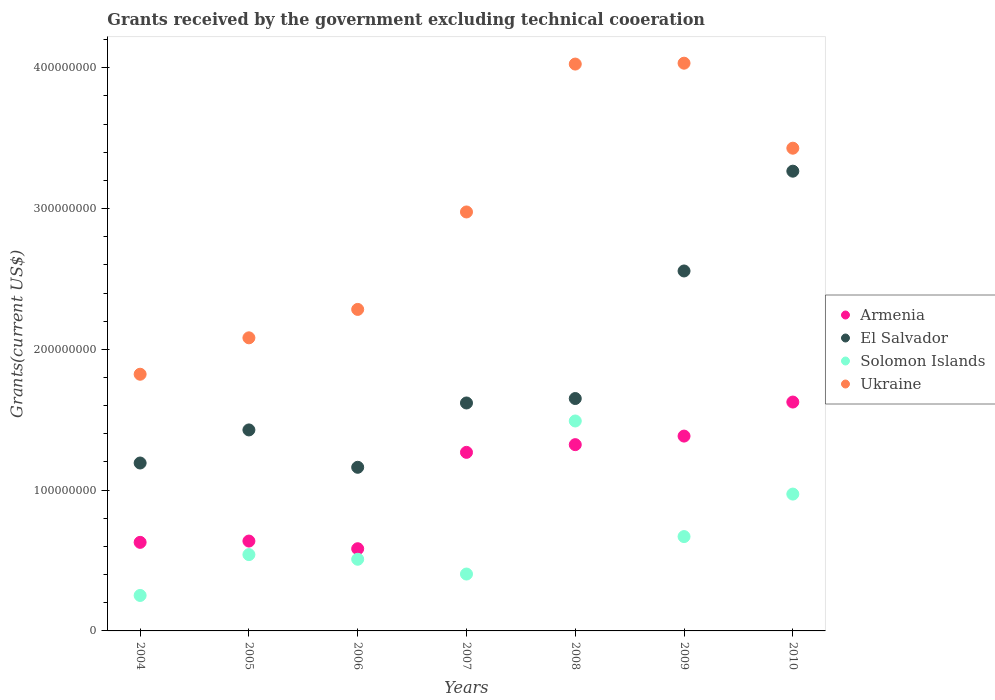How many different coloured dotlines are there?
Offer a terse response. 4. What is the total grants received by the government in Solomon Islands in 2009?
Offer a very short reply. 6.70e+07. Across all years, what is the maximum total grants received by the government in Ukraine?
Give a very brief answer. 4.03e+08. Across all years, what is the minimum total grants received by the government in Armenia?
Make the answer very short. 5.84e+07. In which year was the total grants received by the government in Armenia maximum?
Provide a short and direct response. 2010. In which year was the total grants received by the government in El Salvador minimum?
Your answer should be compact. 2006. What is the total total grants received by the government in El Salvador in the graph?
Your answer should be very brief. 1.29e+09. What is the difference between the total grants received by the government in Ukraine in 2006 and that in 2008?
Provide a short and direct response. -1.74e+08. What is the difference between the total grants received by the government in El Salvador in 2004 and the total grants received by the government in Solomon Islands in 2008?
Your answer should be very brief. -2.98e+07. What is the average total grants received by the government in El Salvador per year?
Your response must be concise. 1.84e+08. In the year 2007, what is the difference between the total grants received by the government in Ukraine and total grants received by the government in Armenia?
Ensure brevity in your answer.  1.71e+08. What is the ratio of the total grants received by the government in Armenia in 2007 to that in 2009?
Your answer should be compact. 0.92. What is the difference between the highest and the second highest total grants received by the government in Armenia?
Provide a short and direct response. 2.42e+07. What is the difference between the highest and the lowest total grants received by the government in Armenia?
Your answer should be very brief. 1.04e+08. In how many years, is the total grants received by the government in Armenia greater than the average total grants received by the government in Armenia taken over all years?
Keep it short and to the point. 4. Is the sum of the total grants received by the government in Ukraine in 2005 and 2009 greater than the maximum total grants received by the government in Armenia across all years?
Provide a short and direct response. Yes. Is the total grants received by the government in Armenia strictly greater than the total grants received by the government in Ukraine over the years?
Ensure brevity in your answer.  No. Is the total grants received by the government in Solomon Islands strictly less than the total grants received by the government in Ukraine over the years?
Offer a terse response. Yes. How many years are there in the graph?
Offer a very short reply. 7. Are the values on the major ticks of Y-axis written in scientific E-notation?
Your answer should be very brief. No. Where does the legend appear in the graph?
Give a very brief answer. Center right. How are the legend labels stacked?
Your answer should be compact. Vertical. What is the title of the graph?
Offer a terse response. Grants received by the government excluding technical cooeration. Does "Fragile and conflict affected situations" appear as one of the legend labels in the graph?
Keep it short and to the point. No. What is the label or title of the X-axis?
Your answer should be compact. Years. What is the label or title of the Y-axis?
Keep it short and to the point. Grants(current US$). What is the Grants(current US$) in Armenia in 2004?
Provide a short and direct response. 6.29e+07. What is the Grants(current US$) of El Salvador in 2004?
Your answer should be very brief. 1.19e+08. What is the Grants(current US$) in Solomon Islands in 2004?
Your answer should be very brief. 2.52e+07. What is the Grants(current US$) in Ukraine in 2004?
Your response must be concise. 1.82e+08. What is the Grants(current US$) in Armenia in 2005?
Provide a succinct answer. 6.38e+07. What is the Grants(current US$) in El Salvador in 2005?
Keep it short and to the point. 1.43e+08. What is the Grants(current US$) in Solomon Islands in 2005?
Your answer should be very brief. 5.42e+07. What is the Grants(current US$) of Ukraine in 2005?
Keep it short and to the point. 2.08e+08. What is the Grants(current US$) in Armenia in 2006?
Give a very brief answer. 5.84e+07. What is the Grants(current US$) of El Salvador in 2006?
Offer a terse response. 1.16e+08. What is the Grants(current US$) in Solomon Islands in 2006?
Your response must be concise. 5.09e+07. What is the Grants(current US$) of Ukraine in 2006?
Ensure brevity in your answer.  2.28e+08. What is the Grants(current US$) of Armenia in 2007?
Offer a very short reply. 1.27e+08. What is the Grants(current US$) of El Salvador in 2007?
Provide a succinct answer. 1.62e+08. What is the Grants(current US$) of Solomon Islands in 2007?
Provide a short and direct response. 4.04e+07. What is the Grants(current US$) of Ukraine in 2007?
Your response must be concise. 2.98e+08. What is the Grants(current US$) in Armenia in 2008?
Give a very brief answer. 1.32e+08. What is the Grants(current US$) of El Salvador in 2008?
Your response must be concise. 1.65e+08. What is the Grants(current US$) of Solomon Islands in 2008?
Give a very brief answer. 1.49e+08. What is the Grants(current US$) of Ukraine in 2008?
Keep it short and to the point. 4.03e+08. What is the Grants(current US$) of Armenia in 2009?
Provide a succinct answer. 1.38e+08. What is the Grants(current US$) in El Salvador in 2009?
Make the answer very short. 2.56e+08. What is the Grants(current US$) of Solomon Islands in 2009?
Ensure brevity in your answer.  6.70e+07. What is the Grants(current US$) of Ukraine in 2009?
Ensure brevity in your answer.  4.03e+08. What is the Grants(current US$) in Armenia in 2010?
Ensure brevity in your answer.  1.63e+08. What is the Grants(current US$) of El Salvador in 2010?
Offer a terse response. 3.27e+08. What is the Grants(current US$) in Solomon Islands in 2010?
Provide a succinct answer. 9.72e+07. What is the Grants(current US$) in Ukraine in 2010?
Keep it short and to the point. 3.43e+08. Across all years, what is the maximum Grants(current US$) in Armenia?
Provide a succinct answer. 1.63e+08. Across all years, what is the maximum Grants(current US$) of El Salvador?
Your answer should be compact. 3.27e+08. Across all years, what is the maximum Grants(current US$) in Solomon Islands?
Ensure brevity in your answer.  1.49e+08. Across all years, what is the maximum Grants(current US$) of Ukraine?
Give a very brief answer. 4.03e+08. Across all years, what is the minimum Grants(current US$) of Armenia?
Keep it short and to the point. 5.84e+07. Across all years, what is the minimum Grants(current US$) of El Salvador?
Your answer should be very brief. 1.16e+08. Across all years, what is the minimum Grants(current US$) of Solomon Islands?
Provide a short and direct response. 2.52e+07. Across all years, what is the minimum Grants(current US$) of Ukraine?
Your answer should be compact. 1.82e+08. What is the total Grants(current US$) in Armenia in the graph?
Make the answer very short. 7.45e+08. What is the total Grants(current US$) in El Salvador in the graph?
Keep it short and to the point. 1.29e+09. What is the total Grants(current US$) in Solomon Islands in the graph?
Make the answer very short. 4.84e+08. What is the total Grants(current US$) in Ukraine in the graph?
Your answer should be very brief. 2.07e+09. What is the difference between the Grants(current US$) of Armenia in 2004 and that in 2005?
Give a very brief answer. -9.10e+05. What is the difference between the Grants(current US$) in El Salvador in 2004 and that in 2005?
Keep it short and to the point. -2.35e+07. What is the difference between the Grants(current US$) of Solomon Islands in 2004 and that in 2005?
Offer a terse response. -2.90e+07. What is the difference between the Grants(current US$) of Ukraine in 2004 and that in 2005?
Keep it short and to the point. -2.59e+07. What is the difference between the Grants(current US$) in Armenia in 2004 and that in 2006?
Your answer should be very brief. 4.53e+06. What is the difference between the Grants(current US$) in El Salvador in 2004 and that in 2006?
Provide a short and direct response. 3.04e+06. What is the difference between the Grants(current US$) of Solomon Islands in 2004 and that in 2006?
Provide a succinct answer. -2.57e+07. What is the difference between the Grants(current US$) in Ukraine in 2004 and that in 2006?
Ensure brevity in your answer.  -4.60e+07. What is the difference between the Grants(current US$) of Armenia in 2004 and that in 2007?
Keep it short and to the point. -6.39e+07. What is the difference between the Grants(current US$) of El Salvador in 2004 and that in 2007?
Make the answer very short. -4.26e+07. What is the difference between the Grants(current US$) of Solomon Islands in 2004 and that in 2007?
Your response must be concise. -1.52e+07. What is the difference between the Grants(current US$) in Ukraine in 2004 and that in 2007?
Keep it short and to the point. -1.15e+08. What is the difference between the Grants(current US$) in Armenia in 2004 and that in 2008?
Your answer should be compact. -6.94e+07. What is the difference between the Grants(current US$) in El Salvador in 2004 and that in 2008?
Your answer should be very brief. -4.58e+07. What is the difference between the Grants(current US$) of Solomon Islands in 2004 and that in 2008?
Offer a terse response. -1.24e+08. What is the difference between the Grants(current US$) of Ukraine in 2004 and that in 2008?
Keep it short and to the point. -2.20e+08. What is the difference between the Grants(current US$) in Armenia in 2004 and that in 2009?
Make the answer very short. -7.55e+07. What is the difference between the Grants(current US$) in El Salvador in 2004 and that in 2009?
Give a very brief answer. -1.36e+08. What is the difference between the Grants(current US$) of Solomon Islands in 2004 and that in 2009?
Give a very brief answer. -4.18e+07. What is the difference between the Grants(current US$) in Ukraine in 2004 and that in 2009?
Your response must be concise. -2.21e+08. What is the difference between the Grants(current US$) in Armenia in 2004 and that in 2010?
Keep it short and to the point. -9.96e+07. What is the difference between the Grants(current US$) of El Salvador in 2004 and that in 2010?
Provide a short and direct response. -2.07e+08. What is the difference between the Grants(current US$) of Solomon Islands in 2004 and that in 2010?
Offer a terse response. -7.20e+07. What is the difference between the Grants(current US$) of Ukraine in 2004 and that in 2010?
Provide a succinct answer. -1.61e+08. What is the difference between the Grants(current US$) in Armenia in 2005 and that in 2006?
Make the answer very short. 5.44e+06. What is the difference between the Grants(current US$) of El Salvador in 2005 and that in 2006?
Keep it short and to the point. 2.65e+07. What is the difference between the Grants(current US$) in Solomon Islands in 2005 and that in 2006?
Provide a short and direct response. 3.30e+06. What is the difference between the Grants(current US$) in Ukraine in 2005 and that in 2006?
Your answer should be very brief. -2.02e+07. What is the difference between the Grants(current US$) of Armenia in 2005 and that in 2007?
Offer a very short reply. -6.30e+07. What is the difference between the Grants(current US$) in El Salvador in 2005 and that in 2007?
Your response must be concise. -1.91e+07. What is the difference between the Grants(current US$) in Solomon Islands in 2005 and that in 2007?
Offer a very short reply. 1.38e+07. What is the difference between the Grants(current US$) of Ukraine in 2005 and that in 2007?
Your response must be concise. -8.94e+07. What is the difference between the Grants(current US$) in Armenia in 2005 and that in 2008?
Make the answer very short. -6.85e+07. What is the difference between the Grants(current US$) in El Salvador in 2005 and that in 2008?
Provide a short and direct response. -2.23e+07. What is the difference between the Grants(current US$) of Solomon Islands in 2005 and that in 2008?
Ensure brevity in your answer.  -9.49e+07. What is the difference between the Grants(current US$) in Ukraine in 2005 and that in 2008?
Ensure brevity in your answer.  -1.94e+08. What is the difference between the Grants(current US$) of Armenia in 2005 and that in 2009?
Give a very brief answer. -7.46e+07. What is the difference between the Grants(current US$) in El Salvador in 2005 and that in 2009?
Your response must be concise. -1.13e+08. What is the difference between the Grants(current US$) in Solomon Islands in 2005 and that in 2009?
Your response must be concise. -1.28e+07. What is the difference between the Grants(current US$) of Ukraine in 2005 and that in 2009?
Your response must be concise. -1.95e+08. What is the difference between the Grants(current US$) of Armenia in 2005 and that in 2010?
Ensure brevity in your answer.  -9.87e+07. What is the difference between the Grants(current US$) in El Salvador in 2005 and that in 2010?
Provide a short and direct response. -1.84e+08. What is the difference between the Grants(current US$) in Solomon Islands in 2005 and that in 2010?
Your answer should be compact. -4.30e+07. What is the difference between the Grants(current US$) in Ukraine in 2005 and that in 2010?
Keep it short and to the point. -1.35e+08. What is the difference between the Grants(current US$) of Armenia in 2006 and that in 2007?
Your response must be concise. -6.84e+07. What is the difference between the Grants(current US$) of El Salvador in 2006 and that in 2007?
Offer a terse response. -4.57e+07. What is the difference between the Grants(current US$) of Solomon Islands in 2006 and that in 2007?
Ensure brevity in your answer.  1.05e+07. What is the difference between the Grants(current US$) of Ukraine in 2006 and that in 2007?
Make the answer very short. -6.92e+07. What is the difference between the Grants(current US$) of Armenia in 2006 and that in 2008?
Your answer should be compact. -7.39e+07. What is the difference between the Grants(current US$) in El Salvador in 2006 and that in 2008?
Provide a short and direct response. -4.88e+07. What is the difference between the Grants(current US$) in Solomon Islands in 2006 and that in 2008?
Provide a succinct answer. -9.82e+07. What is the difference between the Grants(current US$) of Ukraine in 2006 and that in 2008?
Provide a succinct answer. -1.74e+08. What is the difference between the Grants(current US$) of Armenia in 2006 and that in 2009?
Offer a terse response. -8.00e+07. What is the difference between the Grants(current US$) in El Salvador in 2006 and that in 2009?
Your answer should be very brief. -1.39e+08. What is the difference between the Grants(current US$) in Solomon Islands in 2006 and that in 2009?
Keep it short and to the point. -1.61e+07. What is the difference between the Grants(current US$) in Ukraine in 2006 and that in 2009?
Provide a short and direct response. -1.75e+08. What is the difference between the Grants(current US$) in Armenia in 2006 and that in 2010?
Provide a short and direct response. -1.04e+08. What is the difference between the Grants(current US$) in El Salvador in 2006 and that in 2010?
Keep it short and to the point. -2.10e+08. What is the difference between the Grants(current US$) in Solomon Islands in 2006 and that in 2010?
Provide a short and direct response. -4.63e+07. What is the difference between the Grants(current US$) of Ukraine in 2006 and that in 2010?
Your response must be concise. -1.14e+08. What is the difference between the Grants(current US$) in Armenia in 2007 and that in 2008?
Your answer should be very brief. -5.47e+06. What is the difference between the Grants(current US$) in El Salvador in 2007 and that in 2008?
Offer a very short reply. -3.16e+06. What is the difference between the Grants(current US$) in Solomon Islands in 2007 and that in 2008?
Offer a terse response. -1.09e+08. What is the difference between the Grants(current US$) of Ukraine in 2007 and that in 2008?
Give a very brief answer. -1.05e+08. What is the difference between the Grants(current US$) of Armenia in 2007 and that in 2009?
Your answer should be compact. -1.16e+07. What is the difference between the Grants(current US$) in El Salvador in 2007 and that in 2009?
Ensure brevity in your answer.  -9.38e+07. What is the difference between the Grants(current US$) in Solomon Islands in 2007 and that in 2009?
Make the answer very short. -2.66e+07. What is the difference between the Grants(current US$) in Ukraine in 2007 and that in 2009?
Make the answer very short. -1.06e+08. What is the difference between the Grants(current US$) in Armenia in 2007 and that in 2010?
Your response must be concise. -3.57e+07. What is the difference between the Grants(current US$) of El Salvador in 2007 and that in 2010?
Your response must be concise. -1.65e+08. What is the difference between the Grants(current US$) in Solomon Islands in 2007 and that in 2010?
Offer a very short reply. -5.68e+07. What is the difference between the Grants(current US$) in Ukraine in 2007 and that in 2010?
Offer a very short reply. -4.53e+07. What is the difference between the Grants(current US$) of Armenia in 2008 and that in 2009?
Your response must be concise. -6.08e+06. What is the difference between the Grants(current US$) of El Salvador in 2008 and that in 2009?
Provide a short and direct response. -9.06e+07. What is the difference between the Grants(current US$) in Solomon Islands in 2008 and that in 2009?
Provide a short and direct response. 8.21e+07. What is the difference between the Grants(current US$) of Ukraine in 2008 and that in 2009?
Your answer should be compact. -6.30e+05. What is the difference between the Grants(current US$) in Armenia in 2008 and that in 2010?
Keep it short and to the point. -3.03e+07. What is the difference between the Grants(current US$) in El Salvador in 2008 and that in 2010?
Offer a terse response. -1.61e+08. What is the difference between the Grants(current US$) of Solomon Islands in 2008 and that in 2010?
Give a very brief answer. 5.19e+07. What is the difference between the Grants(current US$) in Ukraine in 2008 and that in 2010?
Keep it short and to the point. 5.98e+07. What is the difference between the Grants(current US$) in Armenia in 2009 and that in 2010?
Your answer should be very brief. -2.42e+07. What is the difference between the Grants(current US$) in El Salvador in 2009 and that in 2010?
Your answer should be compact. -7.09e+07. What is the difference between the Grants(current US$) of Solomon Islands in 2009 and that in 2010?
Give a very brief answer. -3.02e+07. What is the difference between the Grants(current US$) in Ukraine in 2009 and that in 2010?
Your answer should be compact. 6.04e+07. What is the difference between the Grants(current US$) in Armenia in 2004 and the Grants(current US$) in El Salvador in 2005?
Your answer should be compact. -7.98e+07. What is the difference between the Grants(current US$) of Armenia in 2004 and the Grants(current US$) of Solomon Islands in 2005?
Your answer should be very brief. 8.71e+06. What is the difference between the Grants(current US$) of Armenia in 2004 and the Grants(current US$) of Ukraine in 2005?
Give a very brief answer. -1.45e+08. What is the difference between the Grants(current US$) in El Salvador in 2004 and the Grants(current US$) in Solomon Islands in 2005?
Offer a terse response. 6.51e+07. What is the difference between the Grants(current US$) in El Salvador in 2004 and the Grants(current US$) in Ukraine in 2005?
Your answer should be compact. -8.89e+07. What is the difference between the Grants(current US$) of Solomon Islands in 2004 and the Grants(current US$) of Ukraine in 2005?
Keep it short and to the point. -1.83e+08. What is the difference between the Grants(current US$) of Armenia in 2004 and the Grants(current US$) of El Salvador in 2006?
Your answer should be compact. -5.33e+07. What is the difference between the Grants(current US$) of Armenia in 2004 and the Grants(current US$) of Solomon Islands in 2006?
Your response must be concise. 1.20e+07. What is the difference between the Grants(current US$) in Armenia in 2004 and the Grants(current US$) in Ukraine in 2006?
Your answer should be compact. -1.65e+08. What is the difference between the Grants(current US$) in El Salvador in 2004 and the Grants(current US$) in Solomon Islands in 2006?
Keep it short and to the point. 6.84e+07. What is the difference between the Grants(current US$) of El Salvador in 2004 and the Grants(current US$) of Ukraine in 2006?
Your answer should be very brief. -1.09e+08. What is the difference between the Grants(current US$) of Solomon Islands in 2004 and the Grants(current US$) of Ukraine in 2006?
Offer a terse response. -2.03e+08. What is the difference between the Grants(current US$) of Armenia in 2004 and the Grants(current US$) of El Salvador in 2007?
Give a very brief answer. -9.90e+07. What is the difference between the Grants(current US$) of Armenia in 2004 and the Grants(current US$) of Solomon Islands in 2007?
Make the answer very short. 2.25e+07. What is the difference between the Grants(current US$) in Armenia in 2004 and the Grants(current US$) in Ukraine in 2007?
Offer a very short reply. -2.35e+08. What is the difference between the Grants(current US$) of El Salvador in 2004 and the Grants(current US$) of Solomon Islands in 2007?
Your response must be concise. 7.89e+07. What is the difference between the Grants(current US$) of El Salvador in 2004 and the Grants(current US$) of Ukraine in 2007?
Provide a succinct answer. -1.78e+08. What is the difference between the Grants(current US$) of Solomon Islands in 2004 and the Grants(current US$) of Ukraine in 2007?
Keep it short and to the point. -2.72e+08. What is the difference between the Grants(current US$) in Armenia in 2004 and the Grants(current US$) in El Salvador in 2008?
Your answer should be compact. -1.02e+08. What is the difference between the Grants(current US$) of Armenia in 2004 and the Grants(current US$) of Solomon Islands in 2008?
Keep it short and to the point. -8.62e+07. What is the difference between the Grants(current US$) in Armenia in 2004 and the Grants(current US$) in Ukraine in 2008?
Provide a short and direct response. -3.40e+08. What is the difference between the Grants(current US$) in El Salvador in 2004 and the Grants(current US$) in Solomon Islands in 2008?
Give a very brief answer. -2.98e+07. What is the difference between the Grants(current US$) of El Salvador in 2004 and the Grants(current US$) of Ukraine in 2008?
Give a very brief answer. -2.83e+08. What is the difference between the Grants(current US$) in Solomon Islands in 2004 and the Grants(current US$) in Ukraine in 2008?
Provide a succinct answer. -3.77e+08. What is the difference between the Grants(current US$) of Armenia in 2004 and the Grants(current US$) of El Salvador in 2009?
Make the answer very short. -1.93e+08. What is the difference between the Grants(current US$) in Armenia in 2004 and the Grants(current US$) in Solomon Islands in 2009?
Ensure brevity in your answer.  -4.10e+06. What is the difference between the Grants(current US$) in Armenia in 2004 and the Grants(current US$) in Ukraine in 2009?
Give a very brief answer. -3.40e+08. What is the difference between the Grants(current US$) in El Salvador in 2004 and the Grants(current US$) in Solomon Islands in 2009?
Your response must be concise. 5.22e+07. What is the difference between the Grants(current US$) in El Salvador in 2004 and the Grants(current US$) in Ukraine in 2009?
Offer a very short reply. -2.84e+08. What is the difference between the Grants(current US$) in Solomon Islands in 2004 and the Grants(current US$) in Ukraine in 2009?
Keep it short and to the point. -3.78e+08. What is the difference between the Grants(current US$) of Armenia in 2004 and the Grants(current US$) of El Salvador in 2010?
Your answer should be very brief. -2.64e+08. What is the difference between the Grants(current US$) of Armenia in 2004 and the Grants(current US$) of Solomon Islands in 2010?
Your answer should be compact. -3.43e+07. What is the difference between the Grants(current US$) in Armenia in 2004 and the Grants(current US$) in Ukraine in 2010?
Offer a terse response. -2.80e+08. What is the difference between the Grants(current US$) in El Salvador in 2004 and the Grants(current US$) in Solomon Islands in 2010?
Your answer should be very brief. 2.21e+07. What is the difference between the Grants(current US$) of El Salvador in 2004 and the Grants(current US$) of Ukraine in 2010?
Keep it short and to the point. -2.24e+08. What is the difference between the Grants(current US$) in Solomon Islands in 2004 and the Grants(current US$) in Ukraine in 2010?
Provide a succinct answer. -3.18e+08. What is the difference between the Grants(current US$) of Armenia in 2005 and the Grants(current US$) of El Salvador in 2006?
Keep it short and to the point. -5.24e+07. What is the difference between the Grants(current US$) of Armenia in 2005 and the Grants(current US$) of Solomon Islands in 2006?
Offer a terse response. 1.29e+07. What is the difference between the Grants(current US$) in Armenia in 2005 and the Grants(current US$) in Ukraine in 2006?
Give a very brief answer. -1.65e+08. What is the difference between the Grants(current US$) of El Salvador in 2005 and the Grants(current US$) of Solomon Islands in 2006?
Your response must be concise. 9.19e+07. What is the difference between the Grants(current US$) of El Salvador in 2005 and the Grants(current US$) of Ukraine in 2006?
Your answer should be very brief. -8.56e+07. What is the difference between the Grants(current US$) of Solomon Islands in 2005 and the Grants(current US$) of Ukraine in 2006?
Your answer should be compact. -1.74e+08. What is the difference between the Grants(current US$) of Armenia in 2005 and the Grants(current US$) of El Salvador in 2007?
Keep it short and to the point. -9.81e+07. What is the difference between the Grants(current US$) of Armenia in 2005 and the Grants(current US$) of Solomon Islands in 2007?
Give a very brief answer. 2.34e+07. What is the difference between the Grants(current US$) of Armenia in 2005 and the Grants(current US$) of Ukraine in 2007?
Offer a terse response. -2.34e+08. What is the difference between the Grants(current US$) of El Salvador in 2005 and the Grants(current US$) of Solomon Islands in 2007?
Ensure brevity in your answer.  1.02e+08. What is the difference between the Grants(current US$) in El Salvador in 2005 and the Grants(current US$) in Ukraine in 2007?
Make the answer very short. -1.55e+08. What is the difference between the Grants(current US$) in Solomon Islands in 2005 and the Grants(current US$) in Ukraine in 2007?
Provide a short and direct response. -2.43e+08. What is the difference between the Grants(current US$) of Armenia in 2005 and the Grants(current US$) of El Salvador in 2008?
Offer a very short reply. -1.01e+08. What is the difference between the Grants(current US$) of Armenia in 2005 and the Grants(current US$) of Solomon Islands in 2008?
Provide a succinct answer. -8.53e+07. What is the difference between the Grants(current US$) of Armenia in 2005 and the Grants(current US$) of Ukraine in 2008?
Keep it short and to the point. -3.39e+08. What is the difference between the Grants(current US$) of El Salvador in 2005 and the Grants(current US$) of Solomon Islands in 2008?
Make the answer very short. -6.35e+06. What is the difference between the Grants(current US$) in El Salvador in 2005 and the Grants(current US$) in Ukraine in 2008?
Ensure brevity in your answer.  -2.60e+08. What is the difference between the Grants(current US$) of Solomon Islands in 2005 and the Grants(current US$) of Ukraine in 2008?
Ensure brevity in your answer.  -3.48e+08. What is the difference between the Grants(current US$) of Armenia in 2005 and the Grants(current US$) of El Salvador in 2009?
Offer a terse response. -1.92e+08. What is the difference between the Grants(current US$) in Armenia in 2005 and the Grants(current US$) in Solomon Islands in 2009?
Keep it short and to the point. -3.19e+06. What is the difference between the Grants(current US$) in Armenia in 2005 and the Grants(current US$) in Ukraine in 2009?
Provide a short and direct response. -3.39e+08. What is the difference between the Grants(current US$) of El Salvador in 2005 and the Grants(current US$) of Solomon Islands in 2009?
Make the answer very short. 7.58e+07. What is the difference between the Grants(current US$) in El Salvador in 2005 and the Grants(current US$) in Ukraine in 2009?
Your answer should be very brief. -2.60e+08. What is the difference between the Grants(current US$) of Solomon Islands in 2005 and the Grants(current US$) of Ukraine in 2009?
Your answer should be compact. -3.49e+08. What is the difference between the Grants(current US$) of Armenia in 2005 and the Grants(current US$) of El Salvador in 2010?
Your response must be concise. -2.63e+08. What is the difference between the Grants(current US$) of Armenia in 2005 and the Grants(current US$) of Solomon Islands in 2010?
Your answer should be very brief. -3.34e+07. What is the difference between the Grants(current US$) in Armenia in 2005 and the Grants(current US$) in Ukraine in 2010?
Provide a succinct answer. -2.79e+08. What is the difference between the Grants(current US$) of El Salvador in 2005 and the Grants(current US$) of Solomon Islands in 2010?
Provide a short and direct response. 4.56e+07. What is the difference between the Grants(current US$) in El Salvador in 2005 and the Grants(current US$) in Ukraine in 2010?
Ensure brevity in your answer.  -2.00e+08. What is the difference between the Grants(current US$) in Solomon Islands in 2005 and the Grants(current US$) in Ukraine in 2010?
Your response must be concise. -2.89e+08. What is the difference between the Grants(current US$) in Armenia in 2006 and the Grants(current US$) in El Salvador in 2007?
Provide a short and direct response. -1.04e+08. What is the difference between the Grants(current US$) of Armenia in 2006 and the Grants(current US$) of Solomon Islands in 2007?
Give a very brief answer. 1.80e+07. What is the difference between the Grants(current US$) in Armenia in 2006 and the Grants(current US$) in Ukraine in 2007?
Your response must be concise. -2.39e+08. What is the difference between the Grants(current US$) in El Salvador in 2006 and the Grants(current US$) in Solomon Islands in 2007?
Provide a succinct answer. 7.58e+07. What is the difference between the Grants(current US$) of El Salvador in 2006 and the Grants(current US$) of Ukraine in 2007?
Provide a succinct answer. -1.81e+08. What is the difference between the Grants(current US$) of Solomon Islands in 2006 and the Grants(current US$) of Ukraine in 2007?
Provide a short and direct response. -2.47e+08. What is the difference between the Grants(current US$) in Armenia in 2006 and the Grants(current US$) in El Salvador in 2008?
Provide a short and direct response. -1.07e+08. What is the difference between the Grants(current US$) in Armenia in 2006 and the Grants(current US$) in Solomon Islands in 2008?
Ensure brevity in your answer.  -9.07e+07. What is the difference between the Grants(current US$) in Armenia in 2006 and the Grants(current US$) in Ukraine in 2008?
Your answer should be compact. -3.44e+08. What is the difference between the Grants(current US$) of El Salvador in 2006 and the Grants(current US$) of Solomon Islands in 2008?
Ensure brevity in your answer.  -3.29e+07. What is the difference between the Grants(current US$) of El Salvador in 2006 and the Grants(current US$) of Ukraine in 2008?
Provide a short and direct response. -2.86e+08. What is the difference between the Grants(current US$) of Solomon Islands in 2006 and the Grants(current US$) of Ukraine in 2008?
Keep it short and to the point. -3.52e+08. What is the difference between the Grants(current US$) of Armenia in 2006 and the Grants(current US$) of El Salvador in 2009?
Offer a very short reply. -1.97e+08. What is the difference between the Grants(current US$) of Armenia in 2006 and the Grants(current US$) of Solomon Islands in 2009?
Give a very brief answer. -8.63e+06. What is the difference between the Grants(current US$) in Armenia in 2006 and the Grants(current US$) in Ukraine in 2009?
Provide a succinct answer. -3.45e+08. What is the difference between the Grants(current US$) in El Salvador in 2006 and the Grants(current US$) in Solomon Islands in 2009?
Your answer should be compact. 4.92e+07. What is the difference between the Grants(current US$) of El Salvador in 2006 and the Grants(current US$) of Ukraine in 2009?
Offer a terse response. -2.87e+08. What is the difference between the Grants(current US$) in Solomon Islands in 2006 and the Grants(current US$) in Ukraine in 2009?
Your answer should be very brief. -3.52e+08. What is the difference between the Grants(current US$) in Armenia in 2006 and the Grants(current US$) in El Salvador in 2010?
Give a very brief answer. -2.68e+08. What is the difference between the Grants(current US$) in Armenia in 2006 and the Grants(current US$) in Solomon Islands in 2010?
Your answer should be very brief. -3.88e+07. What is the difference between the Grants(current US$) of Armenia in 2006 and the Grants(current US$) of Ukraine in 2010?
Make the answer very short. -2.84e+08. What is the difference between the Grants(current US$) of El Salvador in 2006 and the Grants(current US$) of Solomon Islands in 2010?
Keep it short and to the point. 1.90e+07. What is the difference between the Grants(current US$) in El Salvador in 2006 and the Grants(current US$) in Ukraine in 2010?
Offer a terse response. -2.27e+08. What is the difference between the Grants(current US$) of Solomon Islands in 2006 and the Grants(current US$) of Ukraine in 2010?
Your answer should be compact. -2.92e+08. What is the difference between the Grants(current US$) in Armenia in 2007 and the Grants(current US$) in El Salvador in 2008?
Your response must be concise. -3.82e+07. What is the difference between the Grants(current US$) in Armenia in 2007 and the Grants(current US$) in Solomon Islands in 2008?
Give a very brief answer. -2.23e+07. What is the difference between the Grants(current US$) in Armenia in 2007 and the Grants(current US$) in Ukraine in 2008?
Offer a very short reply. -2.76e+08. What is the difference between the Grants(current US$) of El Salvador in 2007 and the Grants(current US$) of Solomon Islands in 2008?
Give a very brief answer. 1.28e+07. What is the difference between the Grants(current US$) of El Salvador in 2007 and the Grants(current US$) of Ukraine in 2008?
Provide a succinct answer. -2.41e+08. What is the difference between the Grants(current US$) of Solomon Islands in 2007 and the Grants(current US$) of Ukraine in 2008?
Offer a terse response. -3.62e+08. What is the difference between the Grants(current US$) in Armenia in 2007 and the Grants(current US$) in El Salvador in 2009?
Offer a terse response. -1.29e+08. What is the difference between the Grants(current US$) of Armenia in 2007 and the Grants(current US$) of Solomon Islands in 2009?
Give a very brief answer. 5.98e+07. What is the difference between the Grants(current US$) in Armenia in 2007 and the Grants(current US$) in Ukraine in 2009?
Your answer should be compact. -2.76e+08. What is the difference between the Grants(current US$) of El Salvador in 2007 and the Grants(current US$) of Solomon Islands in 2009?
Give a very brief answer. 9.49e+07. What is the difference between the Grants(current US$) of El Salvador in 2007 and the Grants(current US$) of Ukraine in 2009?
Offer a very short reply. -2.41e+08. What is the difference between the Grants(current US$) of Solomon Islands in 2007 and the Grants(current US$) of Ukraine in 2009?
Provide a short and direct response. -3.63e+08. What is the difference between the Grants(current US$) of Armenia in 2007 and the Grants(current US$) of El Salvador in 2010?
Your answer should be compact. -2.00e+08. What is the difference between the Grants(current US$) in Armenia in 2007 and the Grants(current US$) in Solomon Islands in 2010?
Keep it short and to the point. 2.96e+07. What is the difference between the Grants(current US$) of Armenia in 2007 and the Grants(current US$) of Ukraine in 2010?
Provide a succinct answer. -2.16e+08. What is the difference between the Grants(current US$) in El Salvador in 2007 and the Grants(current US$) in Solomon Islands in 2010?
Keep it short and to the point. 6.47e+07. What is the difference between the Grants(current US$) of El Salvador in 2007 and the Grants(current US$) of Ukraine in 2010?
Keep it short and to the point. -1.81e+08. What is the difference between the Grants(current US$) of Solomon Islands in 2007 and the Grants(current US$) of Ukraine in 2010?
Your answer should be very brief. -3.02e+08. What is the difference between the Grants(current US$) in Armenia in 2008 and the Grants(current US$) in El Salvador in 2009?
Your answer should be compact. -1.23e+08. What is the difference between the Grants(current US$) of Armenia in 2008 and the Grants(current US$) of Solomon Islands in 2009?
Your answer should be very brief. 6.53e+07. What is the difference between the Grants(current US$) of Armenia in 2008 and the Grants(current US$) of Ukraine in 2009?
Your answer should be compact. -2.71e+08. What is the difference between the Grants(current US$) in El Salvador in 2008 and the Grants(current US$) in Solomon Islands in 2009?
Offer a very short reply. 9.80e+07. What is the difference between the Grants(current US$) in El Salvador in 2008 and the Grants(current US$) in Ukraine in 2009?
Provide a succinct answer. -2.38e+08. What is the difference between the Grants(current US$) in Solomon Islands in 2008 and the Grants(current US$) in Ukraine in 2009?
Your answer should be compact. -2.54e+08. What is the difference between the Grants(current US$) of Armenia in 2008 and the Grants(current US$) of El Salvador in 2010?
Your response must be concise. -1.94e+08. What is the difference between the Grants(current US$) in Armenia in 2008 and the Grants(current US$) in Solomon Islands in 2010?
Make the answer very short. 3.51e+07. What is the difference between the Grants(current US$) in Armenia in 2008 and the Grants(current US$) in Ukraine in 2010?
Your response must be concise. -2.11e+08. What is the difference between the Grants(current US$) of El Salvador in 2008 and the Grants(current US$) of Solomon Islands in 2010?
Offer a very short reply. 6.79e+07. What is the difference between the Grants(current US$) in El Salvador in 2008 and the Grants(current US$) in Ukraine in 2010?
Offer a terse response. -1.78e+08. What is the difference between the Grants(current US$) of Solomon Islands in 2008 and the Grants(current US$) of Ukraine in 2010?
Your response must be concise. -1.94e+08. What is the difference between the Grants(current US$) of Armenia in 2009 and the Grants(current US$) of El Salvador in 2010?
Provide a short and direct response. -1.88e+08. What is the difference between the Grants(current US$) of Armenia in 2009 and the Grants(current US$) of Solomon Islands in 2010?
Offer a very short reply. 4.12e+07. What is the difference between the Grants(current US$) in Armenia in 2009 and the Grants(current US$) in Ukraine in 2010?
Make the answer very short. -2.04e+08. What is the difference between the Grants(current US$) of El Salvador in 2009 and the Grants(current US$) of Solomon Islands in 2010?
Your answer should be very brief. 1.58e+08. What is the difference between the Grants(current US$) of El Salvador in 2009 and the Grants(current US$) of Ukraine in 2010?
Provide a succinct answer. -8.72e+07. What is the difference between the Grants(current US$) of Solomon Islands in 2009 and the Grants(current US$) of Ukraine in 2010?
Keep it short and to the point. -2.76e+08. What is the average Grants(current US$) of Armenia per year?
Offer a very short reply. 1.06e+08. What is the average Grants(current US$) in El Salvador per year?
Your response must be concise. 1.84e+08. What is the average Grants(current US$) in Solomon Islands per year?
Your answer should be compact. 6.91e+07. What is the average Grants(current US$) in Ukraine per year?
Your answer should be very brief. 2.95e+08. In the year 2004, what is the difference between the Grants(current US$) of Armenia and Grants(current US$) of El Salvador?
Give a very brief answer. -5.64e+07. In the year 2004, what is the difference between the Grants(current US$) of Armenia and Grants(current US$) of Solomon Islands?
Offer a very short reply. 3.77e+07. In the year 2004, what is the difference between the Grants(current US$) in Armenia and Grants(current US$) in Ukraine?
Keep it short and to the point. -1.19e+08. In the year 2004, what is the difference between the Grants(current US$) in El Salvador and Grants(current US$) in Solomon Islands?
Make the answer very short. 9.41e+07. In the year 2004, what is the difference between the Grants(current US$) in El Salvador and Grants(current US$) in Ukraine?
Offer a very short reply. -6.30e+07. In the year 2004, what is the difference between the Grants(current US$) of Solomon Islands and Grants(current US$) of Ukraine?
Ensure brevity in your answer.  -1.57e+08. In the year 2005, what is the difference between the Grants(current US$) of Armenia and Grants(current US$) of El Salvador?
Your answer should be compact. -7.89e+07. In the year 2005, what is the difference between the Grants(current US$) of Armenia and Grants(current US$) of Solomon Islands?
Give a very brief answer. 9.62e+06. In the year 2005, what is the difference between the Grants(current US$) in Armenia and Grants(current US$) in Ukraine?
Your response must be concise. -1.44e+08. In the year 2005, what is the difference between the Grants(current US$) in El Salvador and Grants(current US$) in Solomon Islands?
Your answer should be very brief. 8.86e+07. In the year 2005, what is the difference between the Grants(current US$) in El Salvador and Grants(current US$) in Ukraine?
Offer a very short reply. -6.54e+07. In the year 2005, what is the difference between the Grants(current US$) in Solomon Islands and Grants(current US$) in Ukraine?
Keep it short and to the point. -1.54e+08. In the year 2006, what is the difference between the Grants(current US$) of Armenia and Grants(current US$) of El Salvador?
Give a very brief answer. -5.78e+07. In the year 2006, what is the difference between the Grants(current US$) of Armenia and Grants(current US$) of Solomon Islands?
Give a very brief answer. 7.48e+06. In the year 2006, what is the difference between the Grants(current US$) in Armenia and Grants(current US$) in Ukraine?
Give a very brief answer. -1.70e+08. In the year 2006, what is the difference between the Grants(current US$) in El Salvador and Grants(current US$) in Solomon Islands?
Provide a succinct answer. 6.53e+07. In the year 2006, what is the difference between the Grants(current US$) of El Salvador and Grants(current US$) of Ukraine?
Your answer should be very brief. -1.12e+08. In the year 2006, what is the difference between the Grants(current US$) in Solomon Islands and Grants(current US$) in Ukraine?
Offer a terse response. -1.77e+08. In the year 2007, what is the difference between the Grants(current US$) in Armenia and Grants(current US$) in El Salvador?
Make the answer very short. -3.51e+07. In the year 2007, what is the difference between the Grants(current US$) in Armenia and Grants(current US$) in Solomon Islands?
Give a very brief answer. 8.64e+07. In the year 2007, what is the difference between the Grants(current US$) of Armenia and Grants(current US$) of Ukraine?
Keep it short and to the point. -1.71e+08. In the year 2007, what is the difference between the Grants(current US$) in El Salvador and Grants(current US$) in Solomon Islands?
Provide a succinct answer. 1.22e+08. In the year 2007, what is the difference between the Grants(current US$) in El Salvador and Grants(current US$) in Ukraine?
Your response must be concise. -1.36e+08. In the year 2007, what is the difference between the Grants(current US$) of Solomon Islands and Grants(current US$) of Ukraine?
Provide a short and direct response. -2.57e+08. In the year 2008, what is the difference between the Grants(current US$) in Armenia and Grants(current US$) in El Salvador?
Ensure brevity in your answer.  -3.28e+07. In the year 2008, what is the difference between the Grants(current US$) in Armenia and Grants(current US$) in Solomon Islands?
Provide a succinct answer. -1.68e+07. In the year 2008, what is the difference between the Grants(current US$) in Armenia and Grants(current US$) in Ukraine?
Offer a terse response. -2.70e+08. In the year 2008, what is the difference between the Grants(current US$) of El Salvador and Grants(current US$) of Solomon Islands?
Provide a short and direct response. 1.60e+07. In the year 2008, what is the difference between the Grants(current US$) of El Salvador and Grants(current US$) of Ukraine?
Make the answer very short. -2.38e+08. In the year 2008, what is the difference between the Grants(current US$) of Solomon Islands and Grants(current US$) of Ukraine?
Keep it short and to the point. -2.54e+08. In the year 2009, what is the difference between the Grants(current US$) in Armenia and Grants(current US$) in El Salvador?
Provide a succinct answer. -1.17e+08. In the year 2009, what is the difference between the Grants(current US$) in Armenia and Grants(current US$) in Solomon Islands?
Make the answer very short. 7.14e+07. In the year 2009, what is the difference between the Grants(current US$) of Armenia and Grants(current US$) of Ukraine?
Your response must be concise. -2.65e+08. In the year 2009, what is the difference between the Grants(current US$) of El Salvador and Grants(current US$) of Solomon Islands?
Keep it short and to the point. 1.89e+08. In the year 2009, what is the difference between the Grants(current US$) in El Salvador and Grants(current US$) in Ukraine?
Keep it short and to the point. -1.48e+08. In the year 2009, what is the difference between the Grants(current US$) of Solomon Islands and Grants(current US$) of Ukraine?
Provide a succinct answer. -3.36e+08. In the year 2010, what is the difference between the Grants(current US$) of Armenia and Grants(current US$) of El Salvador?
Your answer should be compact. -1.64e+08. In the year 2010, what is the difference between the Grants(current US$) of Armenia and Grants(current US$) of Solomon Islands?
Your answer should be very brief. 6.54e+07. In the year 2010, what is the difference between the Grants(current US$) of Armenia and Grants(current US$) of Ukraine?
Provide a short and direct response. -1.80e+08. In the year 2010, what is the difference between the Grants(current US$) of El Salvador and Grants(current US$) of Solomon Islands?
Ensure brevity in your answer.  2.29e+08. In the year 2010, what is the difference between the Grants(current US$) in El Salvador and Grants(current US$) in Ukraine?
Your response must be concise. -1.63e+07. In the year 2010, what is the difference between the Grants(current US$) in Solomon Islands and Grants(current US$) in Ukraine?
Provide a short and direct response. -2.46e+08. What is the ratio of the Grants(current US$) in Armenia in 2004 to that in 2005?
Ensure brevity in your answer.  0.99. What is the ratio of the Grants(current US$) in El Salvador in 2004 to that in 2005?
Your answer should be very brief. 0.84. What is the ratio of the Grants(current US$) of Solomon Islands in 2004 to that in 2005?
Provide a succinct answer. 0.46. What is the ratio of the Grants(current US$) of Ukraine in 2004 to that in 2005?
Ensure brevity in your answer.  0.88. What is the ratio of the Grants(current US$) of Armenia in 2004 to that in 2006?
Provide a short and direct response. 1.08. What is the ratio of the Grants(current US$) in El Salvador in 2004 to that in 2006?
Keep it short and to the point. 1.03. What is the ratio of the Grants(current US$) in Solomon Islands in 2004 to that in 2006?
Offer a very short reply. 0.49. What is the ratio of the Grants(current US$) of Ukraine in 2004 to that in 2006?
Give a very brief answer. 0.8. What is the ratio of the Grants(current US$) in Armenia in 2004 to that in 2007?
Ensure brevity in your answer.  0.5. What is the ratio of the Grants(current US$) in El Salvador in 2004 to that in 2007?
Your response must be concise. 0.74. What is the ratio of the Grants(current US$) of Solomon Islands in 2004 to that in 2007?
Provide a succinct answer. 0.62. What is the ratio of the Grants(current US$) in Ukraine in 2004 to that in 2007?
Provide a succinct answer. 0.61. What is the ratio of the Grants(current US$) in Armenia in 2004 to that in 2008?
Offer a terse response. 0.48. What is the ratio of the Grants(current US$) of El Salvador in 2004 to that in 2008?
Offer a very short reply. 0.72. What is the ratio of the Grants(current US$) of Solomon Islands in 2004 to that in 2008?
Ensure brevity in your answer.  0.17. What is the ratio of the Grants(current US$) in Ukraine in 2004 to that in 2008?
Offer a very short reply. 0.45. What is the ratio of the Grants(current US$) in Armenia in 2004 to that in 2009?
Your answer should be compact. 0.45. What is the ratio of the Grants(current US$) of El Salvador in 2004 to that in 2009?
Offer a very short reply. 0.47. What is the ratio of the Grants(current US$) in Solomon Islands in 2004 to that in 2009?
Your answer should be very brief. 0.38. What is the ratio of the Grants(current US$) of Ukraine in 2004 to that in 2009?
Keep it short and to the point. 0.45. What is the ratio of the Grants(current US$) in Armenia in 2004 to that in 2010?
Ensure brevity in your answer.  0.39. What is the ratio of the Grants(current US$) in El Salvador in 2004 to that in 2010?
Your answer should be very brief. 0.37. What is the ratio of the Grants(current US$) in Solomon Islands in 2004 to that in 2010?
Offer a terse response. 0.26. What is the ratio of the Grants(current US$) in Ukraine in 2004 to that in 2010?
Provide a succinct answer. 0.53. What is the ratio of the Grants(current US$) in Armenia in 2005 to that in 2006?
Keep it short and to the point. 1.09. What is the ratio of the Grants(current US$) of El Salvador in 2005 to that in 2006?
Keep it short and to the point. 1.23. What is the ratio of the Grants(current US$) of Solomon Islands in 2005 to that in 2006?
Keep it short and to the point. 1.06. What is the ratio of the Grants(current US$) in Ukraine in 2005 to that in 2006?
Give a very brief answer. 0.91. What is the ratio of the Grants(current US$) of Armenia in 2005 to that in 2007?
Give a very brief answer. 0.5. What is the ratio of the Grants(current US$) of El Salvador in 2005 to that in 2007?
Provide a succinct answer. 0.88. What is the ratio of the Grants(current US$) in Solomon Islands in 2005 to that in 2007?
Offer a terse response. 1.34. What is the ratio of the Grants(current US$) of Ukraine in 2005 to that in 2007?
Provide a succinct answer. 0.7. What is the ratio of the Grants(current US$) of Armenia in 2005 to that in 2008?
Offer a terse response. 0.48. What is the ratio of the Grants(current US$) of El Salvador in 2005 to that in 2008?
Provide a short and direct response. 0.86. What is the ratio of the Grants(current US$) in Solomon Islands in 2005 to that in 2008?
Ensure brevity in your answer.  0.36. What is the ratio of the Grants(current US$) of Ukraine in 2005 to that in 2008?
Provide a short and direct response. 0.52. What is the ratio of the Grants(current US$) in Armenia in 2005 to that in 2009?
Provide a short and direct response. 0.46. What is the ratio of the Grants(current US$) in El Salvador in 2005 to that in 2009?
Provide a succinct answer. 0.56. What is the ratio of the Grants(current US$) in Solomon Islands in 2005 to that in 2009?
Ensure brevity in your answer.  0.81. What is the ratio of the Grants(current US$) in Ukraine in 2005 to that in 2009?
Provide a succinct answer. 0.52. What is the ratio of the Grants(current US$) of Armenia in 2005 to that in 2010?
Offer a very short reply. 0.39. What is the ratio of the Grants(current US$) of El Salvador in 2005 to that in 2010?
Ensure brevity in your answer.  0.44. What is the ratio of the Grants(current US$) of Solomon Islands in 2005 to that in 2010?
Your answer should be very brief. 0.56. What is the ratio of the Grants(current US$) in Ukraine in 2005 to that in 2010?
Your response must be concise. 0.61. What is the ratio of the Grants(current US$) of Armenia in 2006 to that in 2007?
Your answer should be compact. 0.46. What is the ratio of the Grants(current US$) of El Salvador in 2006 to that in 2007?
Offer a very short reply. 0.72. What is the ratio of the Grants(current US$) in Solomon Islands in 2006 to that in 2007?
Offer a terse response. 1.26. What is the ratio of the Grants(current US$) in Ukraine in 2006 to that in 2007?
Make the answer very short. 0.77. What is the ratio of the Grants(current US$) in Armenia in 2006 to that in 2008?
Ensure brevity in your answer.  0.44. What is the ratio of the Grants(current US$) in El Salvador in 2006 to that in 2008?
Provide a succinct answer. 0.7. What is the ratio of the Grants(current US$) of Solomon Islands in 2006 to that in 2008?
Ensure brevity in your answer.  0.34. What is the ratio of the Grants(current US$) of Ukraine in 2006 to that in 2008?
Provide a succinct answer. 0.57. What is the ratio of the Grants(current US$) of Armenia in 2006 to that in 2009?
Provide a succinct answer. 0.42. What is the ratio of the Grants(current US$) of El Salvador in 2006 to that in 2009?
Offer a terse response. 0.45. What is the ratio of the Grants(current US$) in Solomon Islands in 2006 to that in 2009?
Your response must be concise. 0.76. What is the ratio of the Grants(current US$) in Ukraine in 2006 to that in 2009?
Provide a succinct answer. 0.57. What is the ratio of the Grants(current US$) of Armenia in 2006 to that in 2010?
Your response must be concise. 0.36. What is the ratio of the Grants(current US$) of El Salvador in 2006 to that in 2010?
Keep it short and to the point. 0.36. What is the ratio of the Grants(current US$) in Solomon Islands in 2006 to that in 2010?
Offer a very short reply. 0.52. What is the ratio of the Grants(current US$) of Ukraine in 2006 to that in 2010?
Your answer should be compact. 0.67. What is the ratio of the Grants(current US$) in Armenia in 2007 to that in 2008?
Your response must be concise. 0.96. What is the ratio of the Grants(current US$) in El Salvador in 2007 to that in 2008?
Your response must be concise. 0.98. What is the ratio of the Grants(current US$) in Solomon Islands in 2007 to that in 2008?
Your answer should be very brief. 0.27. What is the ratio of the Grants(current US$) of Ukraine in 2007 to that in 2008?
Offer a very short reply. 0.74. What is the ratio of the Grants(current US$) in Armenia in 2007 to that in 2009?
Offer a terse response. 0.92. What is the ratio of the Grants(current US$) of El Salvador in 2007 to that in 2009?
Offer a very short reply. 0.63. What is the ratio of the Grants(current US$) of Solomon Islands in 2007 to that in 2009?
Ensure brevity in your answer.  0.6. What is the ratio of the Grants(current US$) of Ukraine in 2007 to that in 2009?
Your answer should be compact. 0.74. What is the ratio of the Grants(current US$) in Armenia in 2007 to that in 2010?
Ensure brevity in your answer.  0.78. What is the ratio of the Grants(current US$) in El Salvador in 2007 to that in 2010?
Keep it short and to the point. 0.5. What is the ratio of the Grants(current US$) in Solomon Islands in 2007 to that in 2010?
Offer a terse response. 0.42. What is the ratio of the Grants(current US$) of Ukraine in 2007 to that in 2010?
Offer a terse response. 0.87. What is the ratio of the Grants(current US$) of Armenia in 2008 to that in 2009?
Ensure brevity in your answer.  0.96. What is the ratio of the Grants(current US$) of El Salvador in 2008 to that in 2009?
Keep it short and to the point. 0.65. What is the ratio of the Grants(current US$) of Solomon Islands in 2008 to that in 2009?
Keep it short and to the point. 2.23. What is the ratio of the Grants(current US$) in Armenia in 2008 to that in 2010?
Provide a succinct answer. 0.81. What is the ratio of the Grants(current US$) in El Salvador in 2008 to that in 2010?
Provide a succinct answer. 0.51. What is the ratio of the Grants(current US$) in Solomon Islands in 2008 to that in 2010?
Your response must be concise. 1.53. What is the ratio of the Grants(current US$) of Ukraine in 2008 to that in 2010?
Your response must be concise. 1.17. What is the ratio of the Grants(current US$) of Armenia in 2009 to that in 2010?
Give a very brief answer. 0.85. What is the ratio of the Grants(current US$) in El Salvador in 2009 to that in 2010?
Make the answer very short. 0.78. What is the ratio of the Grants(current US$) of Solomon Islands in 2009 to that in 2010?
Your answer should be very brief. 0.69. What is the ratio of the Grants(current US$) of Ukraine in 2009 to that in 2010?
Ensure brevity in your answer.  1.18. What is the difference between the highest and the second highest Grants(current US$) of Armenia?
Your answer should be very brief. 2.42e+07. What is the difference between the highest and the second highest Grants(current US$) in El Salvador?
Give a very brief answer. 7.09e+07. What is the difference between the highest and the second highest Grants(current US$) in Solomon Islands?
Make the answer very short. 5.19e+07. What is the difference between the highest and the second highest Grants(current US$) of Ukraine?
Give a very brief answer. 6.30e+05. What is the difference between the highest and the lowest Grants(current US$) in Armenia?
Offer a very short reply. 1.04e+08. What is the difference between the highest and the lowest Grants(current US$) in El Salvador?
Offer a terse response. 2.10e+08. What is the difference between the highest and the lowest Grants(current US$) of Solomon Islands?
Offer a terse response. 1.24e+08. What is the difference between the highest and the lowest Grants(current US$) in Ukraine?
Your answer should be very brief. 2.21e+08. 